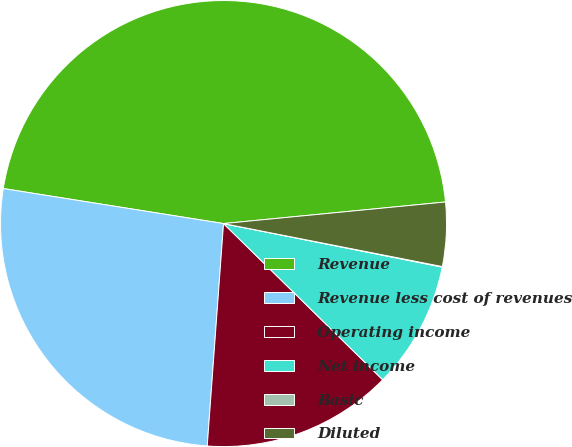Convert chart to OTSL. <chart><loc_0><loc_0><loc_500><loc_500><pie_chart><fcel>Revenue<fcel>Revenue less cost of revenues<fcel>Operating income<fcel>Net income<fcel>Basic<fcel>Diluted<nl><fcel>45.94%<fcel>26.34%<fcel>13.81%<fcel>9.22%<fcel>0.04%<fcel>4.63%<nl></chart> 